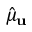<formula> <loc_0><loc_0><loc_500><loc_500>\hat { \mu } _ { u }</formula> 